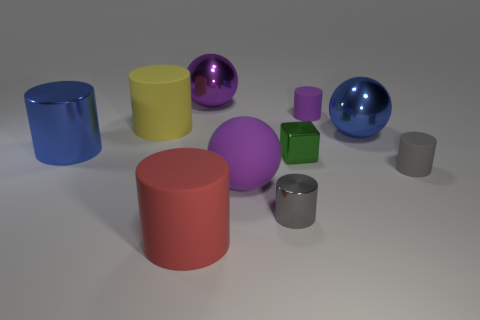There is a tiny rubber object that is the same color as the matte sphere; what shape is it?
Ensure brevity in your answer.  Cylinder. There is a small gray thing behind the big purple matte thing; is its shape the same as the large rubber object that is left of the large red matte cylinder?
Your response must be concise. Yes. What size is the rubber object that is the same color as the tiny metal cylinder?
Offer a terse response. Small. What number of other things are there of the same size as the blue cylinder?
Your answer should be compact. 5. Is the color of the big shiny cylinder the same as the metallic sphere that is right of the green block?
Make the answer very short. Yes. Are there fewer tiny matte things that are behind the big shiny cylinder than small gray objects that are in front of the tiny purple matte cylinder?
Your answer should be compact. Yes. What is the color of the rubber cylinder that is to the left of the tiny purple matte cylinder and behind the red matte object?
Your answer should be very brief. Yellow. Does the red thing have the same size as the blue thing in front of the blue metal sphere?
Your answer should be very brief. Yes. What is the shape of the large metal object to the left of the yellow cylinder?
Give a very brief answer. Cylinder. Is the number of metal cylinders left of the blue metallic cylinder greater than the number of gray shiny cylinders?
Your answer should be compact. No. 